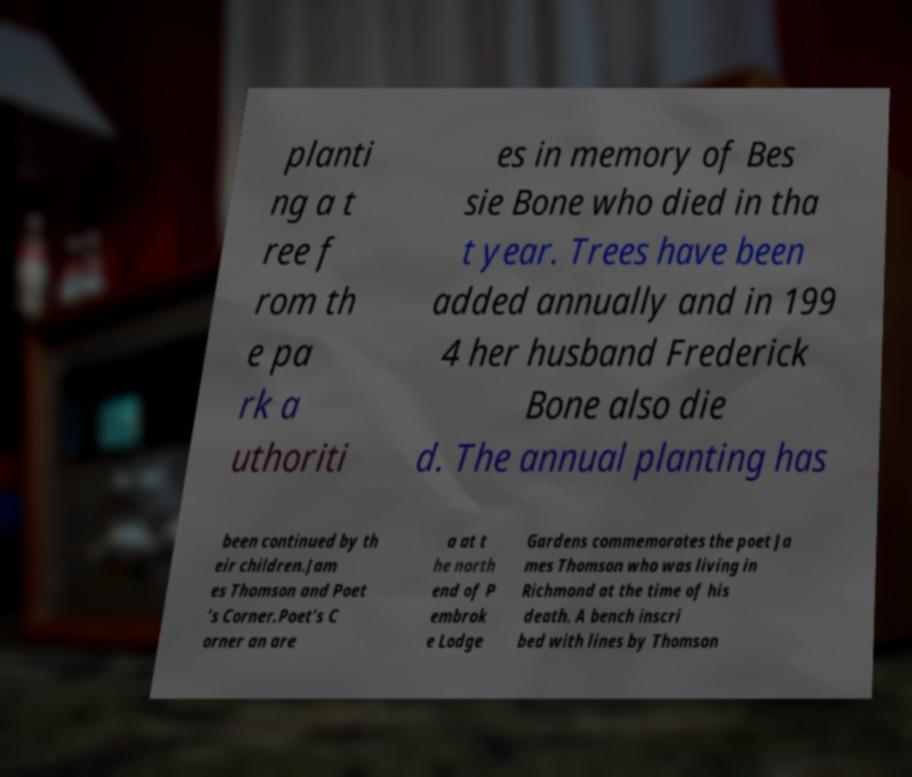Please read and relay the text visible in this image. What does it say? planti ng a t ree f rom th e pa rk a uthoriti es in memory of Bes sie Bone who died in tha t year. Trees have been added annually and in 199 4 her husband Frederick Bone also die d. The annual planting has been continued by th eir children.Jam es Thomson and Poet 's Corner.Poet's C orner an are a at t he north end of P embrok e Lodge Gardens commemorates the poet Ja mes Thomson who was living in Richmond at the time of his death. A bench inscri bed with lines by Thomson 